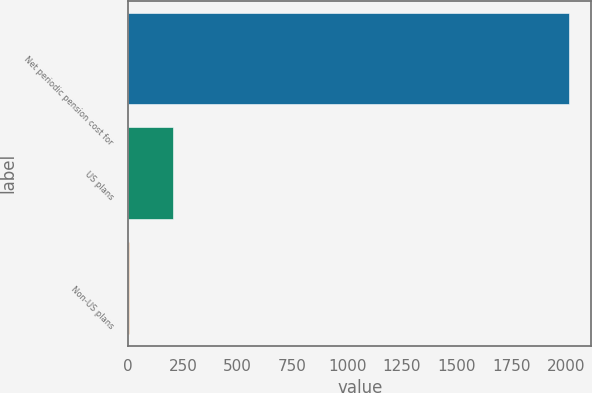<chart> <loc_0><loc_0><loc_500><loc_500><bar_chart><fcel>Net periodic pension cost for<fcel>US plans<fcel>Non-US plans<nl><fcel>2013<fcel>205.35<fcel>4.5<nl></chart> 